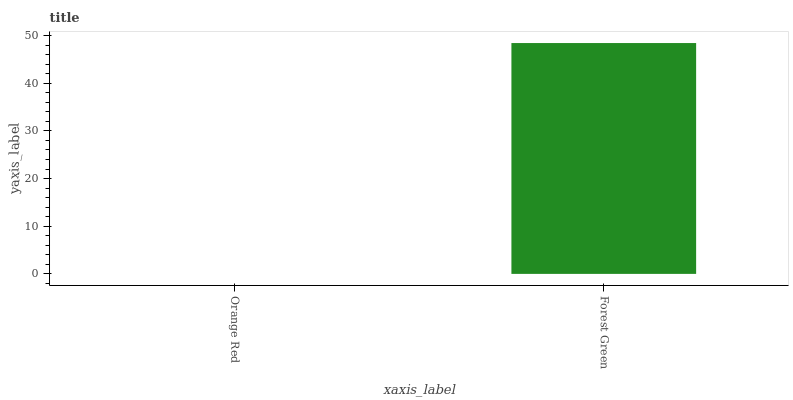Is Forest Green the minimum?
Answer yes or no. No. Is Forest Green greater than Orange Red?
Answer yes or no. Yes. Is Orange Red less than Forest Green?
Answer yes or no. Yes. Is Orange Red greater than Forest Green?
Answer yes or no. No. Is Forest Green less than Orange Red?
Answer yes or no. No. Is Forest Green the high median?
Answer yes or no. Yes. Is Orange Red the low median?
Answer yes or no. Yes. Is Orange Red the high median?
Answer yes or no. No. Is Forest Green the low median?
Answer yes or no. No. 